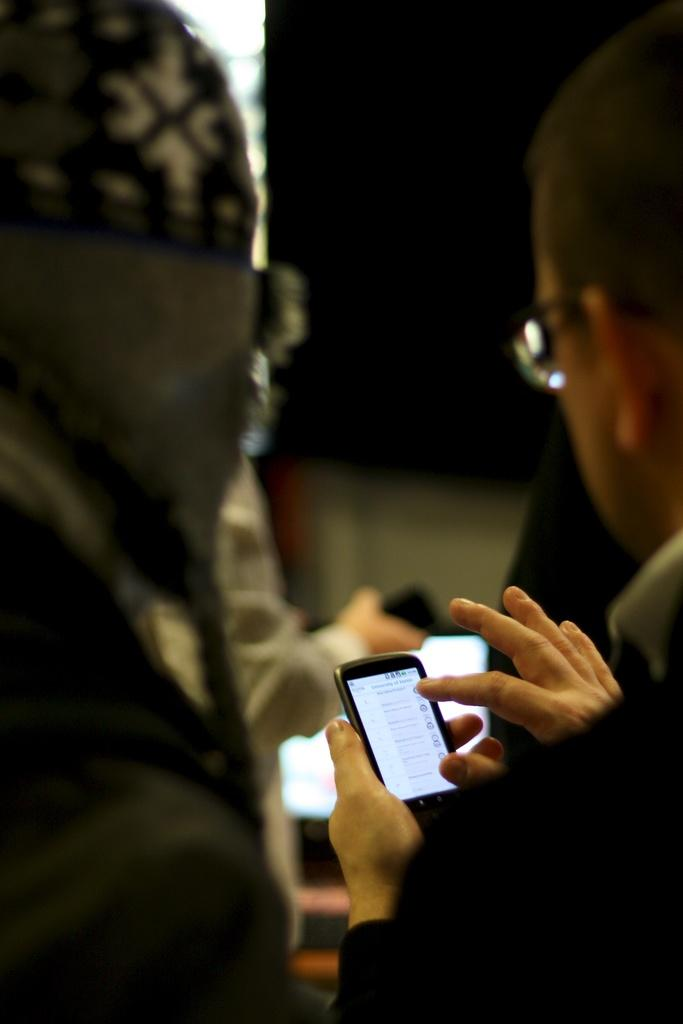How many people are in the image? There are two persons in the image. What are the two persons doing in the image? The two persons are sitting. Which person is holding a mobile phone in the image? The person on the right side of the image is holding a mobile phone in their hands. What type of development can be seen in the background of the image? There is no development visible in the background of the image. What is the condition of the person's nails in the image? There is no information about the person's nails in the image. 